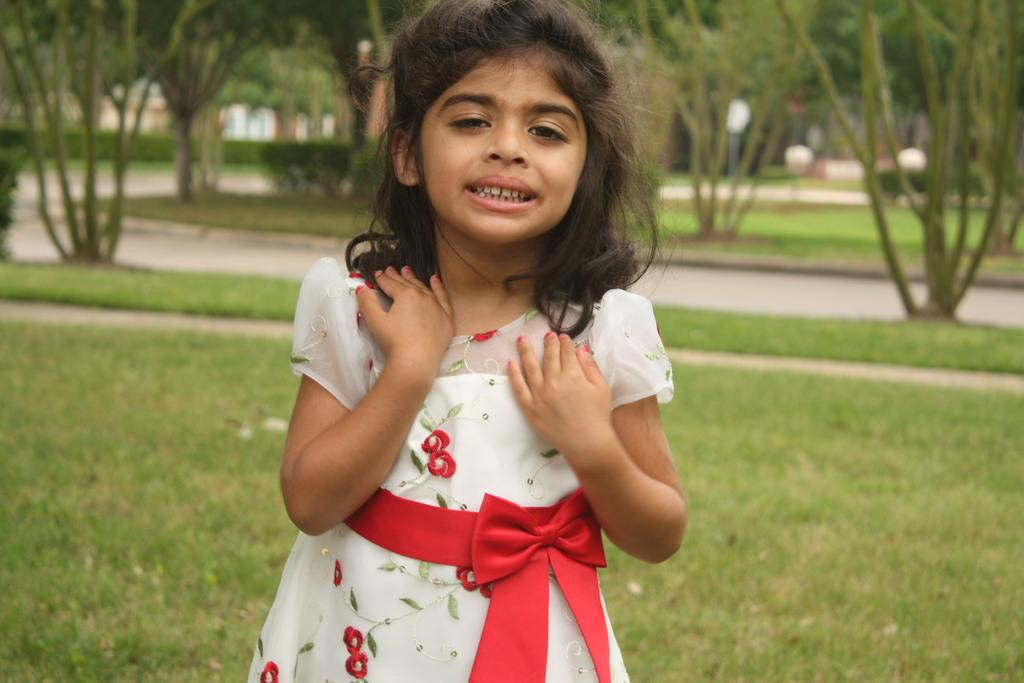Who is the main subject in the foreground of the image? There is a girl in the foreground of the image. What is the girl wearing? The girl is wearing a white frock. What can be seen in the background of the image? There are trees and buildings in the background of the image. What type of terrain is visible in the image? There is grass on the ground in the image. What type of silver material is draped over the canvas in the image? There is no silver material or canvas present in the image. Can you describe the feather accessories worn by the girl in the image? There are no feather accessories mentioned or visible in the image. 